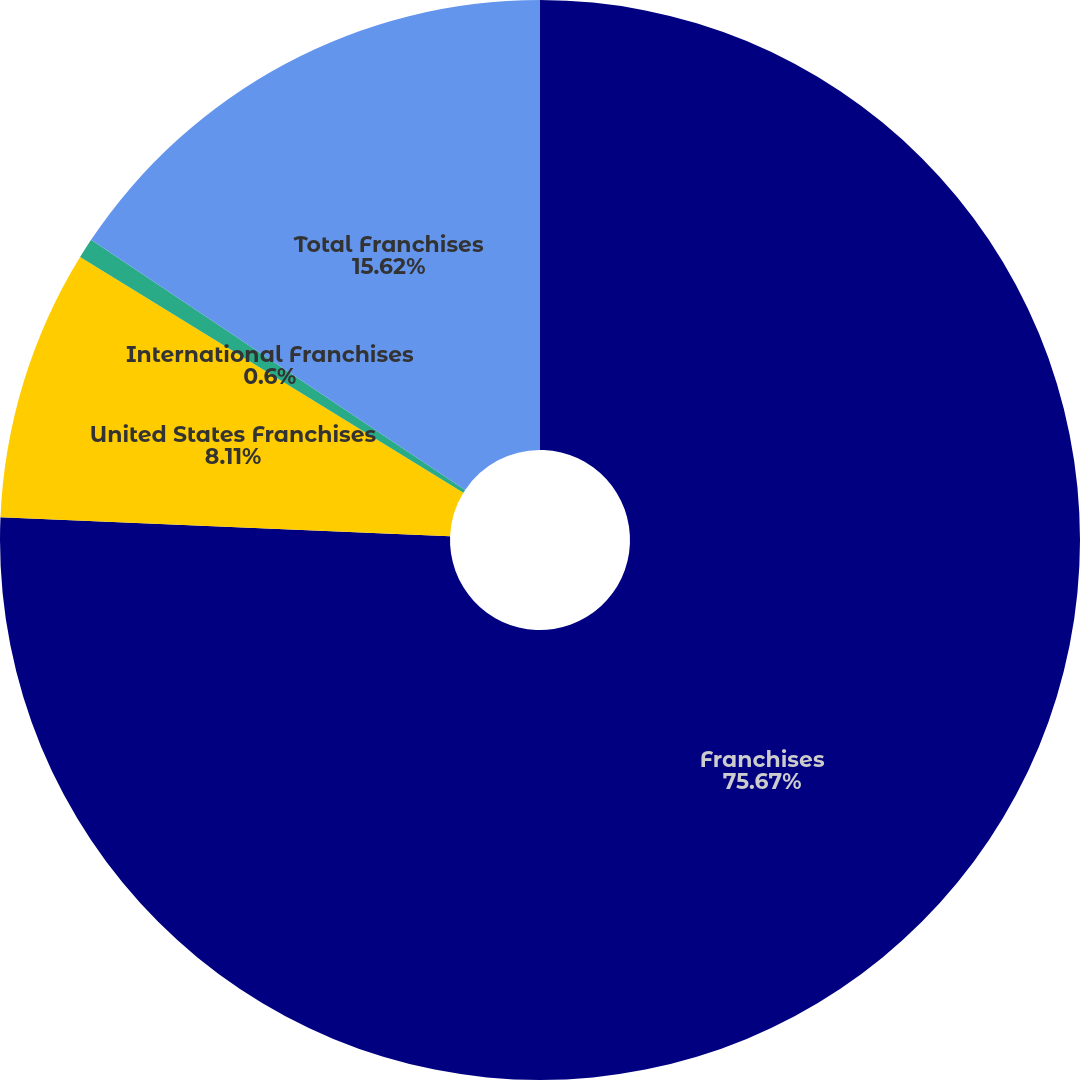Convert chart to OTSL. <chart><loc_0><loc_0><loc_500><loc_500><pie_chart><fcel>Franchises<fcel>United States Franchises<fcel>International Franchises<fcel>Total Franchises<nl><fcel>75.67%<fcel>8.11%<fcel>0.6%<fcel>15.62%<nl></chart> 